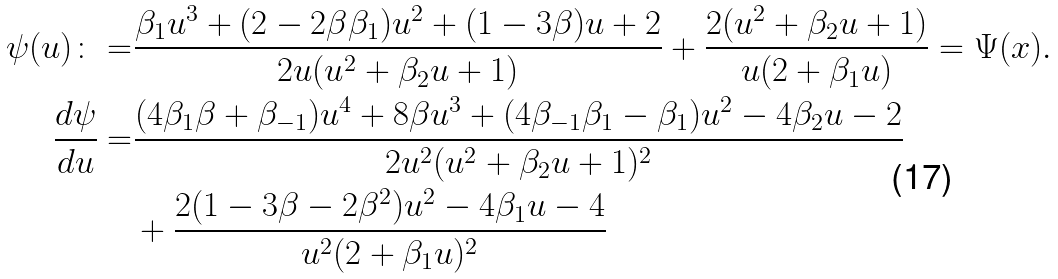<formula> <loc_0><loc_0><loc_500><loc_500>\psi ( u ) \colon = & \frac { \beta _ { 1 } u ^ { 3 } + ( 2 - 2 \beta \beta _ { 1 } ) u ^ { 2 } + ( 1 - 3 \beta ) u + 2 } { 2 u ( u ^ { 2 } + \beta _ { 2 } u + 1 ) } + \frac { 2 ( u ^ { 2 } + \beta _ { 2 } u + 1 ) } { u ( 2 + \beta _ { 1 } u ) } = \Psi ( { x } ) . \\ \frac { d \psi } { d u } = & \frac { ( 4 \beta _ { 1 } \beta + \beta _ { - 1 } ) u ^ { 4 } + 8 \beta u ^ { 3 } + ( 4 \beta _ { - 1 } \beta _ { 1 } - \beta _ { 1 } ) u ^ { 2 } - 4 \beta _ { 2 } u - 2 } { 2 u ^ { 2 } ( u ^ { 2 } + \beta _ { 2 } u + 1 ) ^ { 2 } } \\ & + \frac { 2 ( 1 - 3 \beta - 2 \beta ^ { 2 } ) u ^ { 2 } - 4 \beta _ { 1 } u - 4 } { u ^ { 2 } ( 2 + \beta _ { 1 } u ) ^ { 2 } }</formula> 